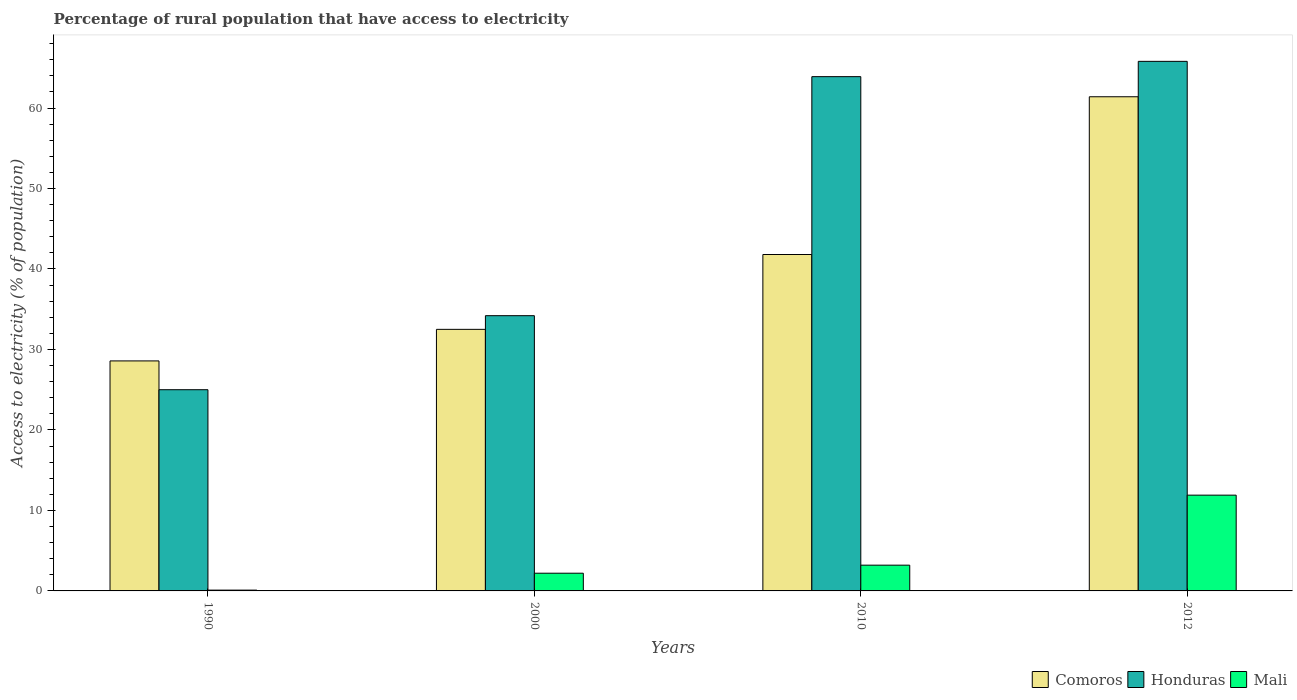How many groups of bars are there?
Offer a very short reply. 4. Are the number of bars per tick equal to the number of legend labels?
Give a very brief answer. Yes. Are the number of bars on each tick of the X-axis equal?
Your answer should be compact. Yes. How many bars are there on the 1st tick from the left?
Provide a succinct answer. 3. What is the label of the 1st group of bars from the left?
Give a very brief answer. 1990. In how many cases, is the number of bars for a given year not equal to the number of legend labels?
Provide a short and direct response. 0. What is the percentage of rural population that have access to electricity in Comoros in 2000?
Your response must be concise. 32.5. Across all years, what is the maximum percentage of rural population that have access to electricity in Comoros?
Offer a very short reply. 61.4. Across all years, what is the minimum percentage of rural population that have access to electricity in Honduras?
Ensure brevity in your answer.  25. In which year was the percentage of rural population that have access to electricity in Comoros maximum?
Offer a terse response. 2012. In which year was the percentage of rural population that have access to electricity in Honduras minimum?
Keep it short and to the point. 1990. What is the total percentage of rural population that have access to electricity in Comoros in the graph?
Make the answer very short. 164.28. What is the difference between the percentage of rural population that have access to electricity in Honduras in 1990 and that in 2010?
Your answer should be very brief. -38.9. What is the difference between the percentage of rural population that have access to electricity in Comoros in 2012 and the percentage of rural population that have access to electricity in Honduras in 1990?
Your response must be concise. 36.4. What is the average percentage of rural population that have access to electricity in Mali per year?
Provide a succinct answer. 4.35. In the year 1990, what is the difference between the percentage of rural population that have access to electricity in Comoros and percentage of rural population that have access to electricity in Honduras?
Give a very brief answer. 3.58. In how many years, is the percentage of rural population that have access to electricity in Mali greater than 64 %?
Offer a very short reply. 0. What is the ratio of the percentage of rural population that have access to electricity in Mali in 1990 to that in 2012?
Your response must be concise. 0.01. Is the percentage of rural population that have access to electricity in Honduras in 1990 less than that in 2010?
Provide a succinct answer. Yes. What is the difference between the highest and the second highest percentage of rural population that have access to electricity in Honduras?
Your answer should be compact. 1.9. What is the difference between the highest and the lowest percentage of rural population that have access to electricity in Comoros?
Provide a short and direct response. 32.82. In how many years, is the percentage of rural population that have access to electricity in Mali greater than the average percentage of rural population that have access to electricity in Mali taken over all years?
Give a very brief answer. 1. What does the 1st bar from the left in 2012 represents?
Your response must be concise. Comoros. What does the 1st bar from the right in 2012 represents?
Your answer should be compact. Mali. Is it the case that in every year, the sum of the percentage of rural population that have access to electricity in Mali and percentage of rural population that have access to electricity in Honduras is greater than the percentage of rural population that have access to electricity in Comoros?
Provide a short and direct response. No. How many years are there in the graph?
Make the answer very short. 4. Are the values on the major ticks of Y-axis written in scientific E-notation?
Your response must be concise. No. What is the title of the graph?
Your response must be concise. Percentage of rural population that have access to electricity. What is the label or title of the X-axis?
Your response must be concise. Years. What is the label or title of the Y-axis?
Make the answer very short. Access to electricity (% of population). What is the Access to electricity (% of population) of Comoros in 1990?
Give a very brief answer. 28.58. What is the Access to electricity (% of population) in Honduras in 1990?
Offer a terse response. 25. What is the Access to electricity (% of population) of Comoros in 2000?
Offer a terse response. 32.5. What is the Access to electricity (% of population) of Honduras in 2000?
Keep it short and to the point. 34.2. What is the Access to electricity (% of population) of Mali in 2000?
Your answer should be very brief. 2.2. What is the Access to electricity (% of population) in Comoros in 2010?
Make the answer very short. 41.8. What is the Access to electricity (% of population) of Honduras in 2010?
Ensure brevity in your answer.  63.9. What is the Access to electricity (% of population) of Comoros in 2012?
Offer a very short reply. 61.4. What is the Access to electricity (% of population) of Honduras in 2012?
Your response must be concise. 65.8. Across all years, what is the maximum Access to electricity (% of population) in Comoros?
Ensure brevity in your answer.  61.4. Across all years, what is the maximum Access to electricity (% of population) in Honduras?
Your answer should be very brief. 65.8. Across all years, what is the maximum Access to electricity (% of population) of Mali?
Make the answer very short. 11.9. Across all years, what is the minimum Access to electricity (% of population) of Comoros?
Offer a terse response. 28.58. Across all years, what is the minimum Access to electricity (% of population) in Honduras?
Provide a succinct answer. 25. Across all years, what is the minimum Access to electricity (% of population) of Mali?
Your response must be concise. 0.1. What is the total Access to electricity (% of population) of Comoros in the graph?
Your response must be concise. 164.28. What is the total Access to electricity (% of population) of Honduras in the graph?
Offer a terse response. 188.9. What is the difference between the Access to electricity (% of population) in Comoros in 1990 and that in 2000?
Your answer should be compact. -3.92. What is the difference between the Access to electricity (% of population) of Honduras in 1990 and that in 2000?
Offer a very short reply. -9.2. What is the difference between the Access to electricity (% of population) of Mali in 1990 and that in 2000?
Keep it short and to the point. -2.1. What is the difference between the Access to electricity (% of population) of Comoros in 1990 and that in 2010?
Ensure brevity in your answer.  -13.22. What is the difference between the Access to electricity (% of population) of Honduras in 1990 and that in 2010?
Your response must be concise. -38.9. What is the difference between the Access to electricity (% of population) in Mali in 1990 and that in 2010?
Provide a succinct answer. -3.1. What is the difference between the Access to electricity (% of population) of Comoros in 1990 and that in 2012?
Your answer should be compact. -32.82. What is the difference between the Access to electricity (% of population) of Honduras in 1990 and that in 2012?
Provide a succinct answer. -40.8. What is the difference between the Access to electricity (% of population) in Mali in 1990 and that in 2012?
Make the answer very short. -11.8. What is the difference between the Access to electricity (% of population) of Honduras in 2000 and that in 2010?
Your response must be concise. -29.7. What is the difference between the Access to electricity (% of population) in Mali in 2000 and that in 2010?
Your answer should be compact. -1. What is the difference between the Access to electricity (% of population) of Comoros in 2000 and that in 2012?
Provide a succinct answer. -28.9. What is the difference between the Access to electricity (% of population) in Honduras in 2000 and that in 2012?
Your answer should be very brief. -31.6. What is the difference between the Access to electricity (% of population) of Mali in 2000 and that in 2012?
Make the answer very short. -9.7. What is the difference between the Access to electricity (% of population) of Comoros in 2010 and that in 2012?
Offer a terse response. -19.6. What is the difference between the Access to electricity (% of population) of Comoros in 1990 and the Access to electricity (% of population) of Honduras in 2000?
Your answer should be compact. -5.62. What is the difference between the Access to electricity (% of population) of Comoros in 1990 and the Access to electricity (% of population) of Mali in 2000?
Your response must be concise. 26.38. What is the difference between the Access to electricity (% of population) of Honduras in 1990 and the Access to electricity (% of population) of Mali in 2000?
Make the answer very short. 22.8. What is the difference between the Access to electricity (% of population) of Comoros in 1990 and the Access to electricity (% of population) of Honduras in 2010?
Keep it short and to the point. -35.32. What is the difference between the Access to electricity (% of population) of Comoros in 1990 and the Access to electricity (% of population) of Mali in 2010?
Provide a succinct answer. 25.38. What is the difference between the Access to electricity (% of population) of Honduras in 1990 and the Access to electricity (% of population) of Mali in 2010?
Give a very brief answer. 21.8. What is the difference between the Access to electricity (% of population) of Comoros in 1990 and the Access to electricity (% of population) of Honduras in 2012?
Your answer should be compact. -37.22. What is the difference between the Access to electricity (% of population) of Comoros in 1990 and the Access to electricity (% of population) of Mali in 2012?
Offer a terse response. 16.68. What is the difference between the Access to electricity (% of population) in Honduras in 1990 and the Access to electricity (% of population) in Mali in 2012?
Provide a short and direct response. 13.1. What is the difference between the Access to electricity (% of population) in Comoros in 2000 and the Access to electricity (% of population) in Honduras in 2010?
Give a very brief answer. -31.4. What is the difference between the Access to electricity (% of population) of Comoros in 2000 and the Access to electricity (% of population) of Mali in 2010?
Offer a terse response. 29.3. What is the difference between the Access to electricity (% of population) of Comoros in 2000 and the Access to electricity (% of population) of Honduras in 2012?
Your response must be concise. -33.3. What is the difference between the Access to electricity (% of population) in Comoros in 2000 and the Access to electricity (% of population) in Mali in 2012?
Provide a short and direct response. 20.6. What is the difference between the Access to electricity (% of population) in Honduras in 2000 and the Access to electricity (% of population) in Mali in 2012?
Your response must be concise. 22.3. What is the difference between the Access to electricity (% of population) of Comoros in 2010 and the Access to electricity (% of population) of Honduras in 2012?
Provide a short and direct response. -24. What is the difference between the Access to electricity (% of population) of Comoros in 2010 and the Access to electricity (% of population) of Mali in 2012?
Offer a very short reply. 29.9. What is the average Access to electricity (% of population) in Comoros per year?
Provide a succinct answer. 41.07. What is the average Access to electricity (% of population) in Honduras per year?
Ensure brevity in your answer.  47.23. What is the average Access to electricity (% of population) of Mali per year?
Offer a terse response. 4.35. In the year 1990, what is the difference between the Access to electricity (% of population) of Comoros and Access to electricity (% of population) of Honduras?
Provide a succinct answer. 3.58. In the year 1990, what is the difference between the Access to electricity (% of population) in Comoros and Access to electricity (% of population) in Mali?
Make the answer very short. 28.48. In the year 1990, what is the difference between the Access to electricity (% of population) in Honduras and Access to electricity (% of population) in Mali?
Give a very brief answer. 24.9. In the year 2000, what is the difference between the Access to electricity (% of population) in Comoros and Access to electricity (% of population) in Mali?
Provide a short and direct response. 30.3. In the year 2000, what is the difference between the Access to electricity (% of population) of Honduras and Access to electricity (% of population) of Mali?
Keep it short and to the point. 32. In the year 2010, what is the difference between the Access to electricity (% of population) of Comoros and Access to electricity (% of population) of Honduras?
Your answer should be very brief. -22.1. In the year 2010, what is the difference between the Access to electricity (% of population) in Comoros and Access to electricity (% of population) in Mali?
Your response must be concise. 38.6. In the year 2010, what is the difference between the Access to electricity (% of population) in Honduras and Access to electricity (% of population) in Mali?
Your answer should be very brief. 60.7. In the year 2012, what is the difference between the Access to electricity (% of population) of Comoros and Access to electricity (% of population) of Mali?
Provide a succinct answer. 49.5. In the year 2012, what is the difference between the Access to electricity (% of population) of Honduras and Access to electricity (% of population) of Mali?
Offer a terse response. 53.9. What is the ratio of the Access to electricity (% of population) in Comoros in 1990 to that in 2000?
Provide a short and direct response. 0.88. What is the ratio of the Access to electricity (% of population) of Honduras in 1990 to that in 2000?
Provide a short and direct response. 0.73. What is the ratio of the Access to electricity (% of population) of Mali in 1990 to that in 2000?
Your answer should be compact. 0.05. What is the ratio of the Access to electricity (% of population) of Comoros in 1990 to that in 2010?
Your answer should be very brief. 0.68. What is the ratio of the Access to electricity (% of population) of Honduras in 1990 to that in 2010?
Your answer should be very brief. 0.39. What is the ratio of the Access to electricity (% of population) in Mali in 1990 to that in 2010?
Your answer should be compact. 0.03. What is the ratio of the Access to electricity (% of population) of Comoros in 1990 to that in 2012?
Give a very brief answer. 0.47. What is the ratio of the Access to electricity (% of population) in Honduras in 1990 to that in 2012?
Keep it short and to the point. 0.38. What is the ratio of the Access to electricity (% of population) in Mali in 1990 to that in 2012?
Your answer should be very brief. 0.01. What is the ratio of the Access to electricity (% of population) of Comoros in 2000 to that in 2010?
Your answer should be compact. 0.78. What is the ratio of the Access to electricity (% of population) of Honduras in 2000 to that in 2010?
Make the answer very short. 0.54. What is the ratio of the Access to electricity (% of population) in Mali in 2000 to that in 2010?
Offer a very short reply. 0.69. What is the ratio of the Access to electricity (% of population) of Comoros in 2000 to that in 2012?
Your response must be concise. 0.53. What is the ratio of the Access to electricity (% of population) in Honduras in 2000 to that in 2012?
Keep it short and to the point. 0.52. What is the ratio of the Access to electricity (% of population) of Mali in 2000 to that in 2012?
Ensure brevity in your answer.  0.18. What is the ratio of the Access to electricity (% of population) in Comoros in 2010 to that in 2012?
Offer a terse response. 0.68. What is the ratio of the Access to electricity (% of population) of Honduras in 2010 to that in 2012?
Offer a terse response. 0.97. What is the ratio of the Access to electricity (% of population) of Mali in 2010 to that in 2012?
Your answer should be very brief. 0.27. What is the difference between the highest and the second highest Access to electricity (% of population) of Comoros?
Offer a terse response. 19.6. What is the difference between the highest and the second highest Access to electricity (% of population) in Honduras?
Make the answer very short. 1.9. What is the difference between the highest and the second highest Access to electricity (% of population) in Mali?
Keep it short and to the point. 8.7. What is the difference between the highest and the lowest Access to electricity (% of population) of Comoros?
Offer a very short reply. 32.82. What is the difference between the highest and the lowest Access to electricity (% of population) in Honduras?
Make the answer very short. 40.8. What is the difference between the highest and the lowest Access to electricity (% of population) of Mali?
Provide a short and direct response. 11.8. 